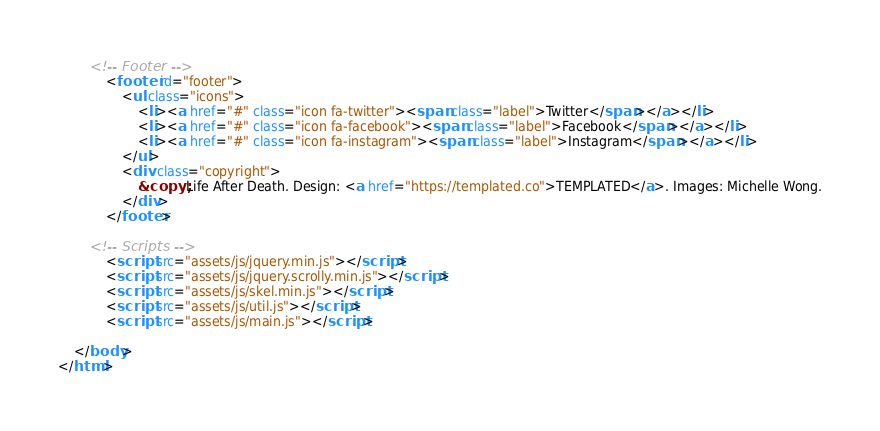Convert code to text. <code><loc_0><loc_0><loc_500><loc_500><_HTML_>
		<!-- Footer -->
			<footer id="footer">
				<ul class="icons">
					<li><a href="#" class="icon fa-twitter"><span class="label">Twitter</span></a></li>
					<li><a href="#" class="icon fa-facebook"><span class="label">Facebook</span></a></li>
					<li><a href="#" class="icon fa-instagram"><span class="label">Instagram</span></a></li>
				</ul>
				<div class="copyright">
					&copy; Life After Death. Design: <a href="https://templated.co">TEMPLATED</a>. Images: Michelle Wong.
				</div>
			</footer>

		<!-- Scripts -->
			<script src="assets/js/jquery.min.js"></script>
			<script src="assets/js/jquery.scrolly.min.js"></script>
			<script src="assets/js/skel.min.js"></script>
			<script src="assets/js/util.js"></script>
			<script src="assets/js/main.js"></script>

	</body>
</html></code> 